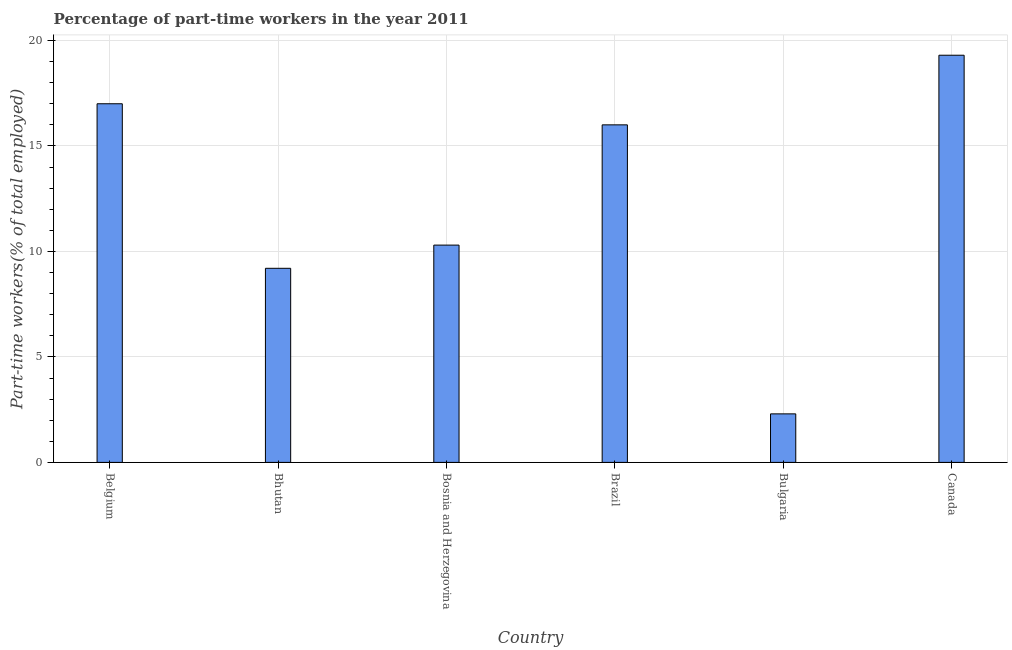Does the graph contain grids?
Your answer should be compact. Yes. What is the title of the graph?
Your answer should be compact. Percentage of part-time workers in the year 2011. What is the label or title of the X-axis?
Provide a short and direct response. Country. What is the label or title of the Y-axis?
Make the answer very short. Part-time workers(% of total employed). Across all countries, what is the maximum percentage of part-time workers?
Your answer should be compact. 19.3. Across all countries, what is the minimum percentage of part-time workers?
Keep it short and to the point. 2.3. In which country was the percentage of part-time workers maximum?
Provide a succinct answer. Canada. What is the sum of the percentage of part-time workers?
Provide a succinct answer. 74.1. What is the average percentage of part-time workers per country?
Give a very brief answer. 12.35. What is the median percentage of part-time workers?
Make the answer very short. 13.15. In how many countries, is the percentage of part-time workers greater than 13 %?
Provide a short and direct response. 3. What is the ratio of the percentage of part-time workers in Bosnia and Herzegovina to that in Bulgaria?
Give a very brief answer. 4.48. Is the difference between the percentage of part-time workers in Bosnia and Herzegovina and Bulgaria greater than the difference between any two countries?
Your response must be concise. No. What is the difference between the highest and the second highest percentage of part-time workers?
Offer a very short reply. 2.3. In how many countries, is the percentage of part-time workers greater than the average percentage of part-time workers taken over all countries?
Keep it short and to the point. 3. How many bars are there?
Your answer should be compact. 6. Are all the bars in the graph horizontal?
Provide a short and direct response. No. What is the Part-time workers(% of total employed) in Bhutan?
Ensure brevity in your answer.  9.2. What is the Part-time workers(% of total employed) in Bosnia and Herzegovina?
Provide a succinct answer. 10.3. What is the Part-time workers(% of total employed) of Bulgaria?
Keep it short and to the point. 2.3. What is the Part-time workers(% of total employed) in Canada?
Offer a terse response. 19.3. What is the difference between the Part-time workers(% of total employed) in Belgium and Bosnia and Herzegovina?
Your answer should be compact. 6.7. What is the difference between the Part-time workers(% of total employed) in Belgium and Brazil?
Make the answer very short. 1. What is the difference between the Part-time workers(% of total employed) in Belgium and Bulgaria?
Keep it short and to the point. 14.7. What is the difference between the Part-time workers(% of total employed) in Belgium and Canada?
Offer a very short reply. -2.3. What is the difference between the Part-time workers(% of total employed) in Bhutan and Brazil?
Offer a terse response. -6.8. What is the difference between the Part-time workers(% of total employed) in Bhutan and Canada?
Your response must be concise. -10.1. What is the difference between the Part-time workers(% of total employed) in Bosnia and Herzegovina and Bulgaria?
Your answer should be very brief. 8. What is the difference between the Part-time workers(% of total employed) in Bosnia and Herzegovina and Canada?
Your answer should be compact. -9. What is the difference between the Part-time workers(% of total employed) in Brazil and Canada?
Ensure brevity in your answer.  -3.3. What is the ratio of the Part-time workers(% of total employed) in Belgium to that in Bhutan?
Give a very brief answer. 1.85. What is the ratio of the Part-time workers(% of total employed) in Belgium to that in Bosnia and Herzegovina?
Provide a succinct answer. 1.65. What is the ratio of the Part-time workers(% of total employed) in Belgium to that in Brazil?
Your answer should be compact. 1.06. What is the ratio of the Part-time workers(% of total employed) in Belgium to that in Bulgaria?
Keep it short and to the point. 7.39. What is the ratio of the Part-time workers(% of total employed) in Belgium to that in Canada?
Offer a terse response. 0.88. What is the ratio of the Part-time workers(% of total employed) in Bhutan to that in Bosnia and Herzegovina?
Make the answer very short. 0.89. What is the ratio of the Part-time workers(% of total employed) in Bhutan to that in Brazil?
Your answer should be very brief. 0.57. What is the ratio of the Part-time workers(% of total employed) in Bhutan to that in Canada?
Your answer should be very brief. 0.48. What is the ratio of the Part-time workers(% of total employed) in Bosnia and Herzegovina to that in Brazil?
Offer a very short reply. 0.64. What is the ratio of the Part-time workers(% of total employed) in Bosnia and Herzegovina to that in Bulgaria?
Ensure brevity in your answer.  4.48. What is the ratio of the Part-time workers(% of total employed) in Bosnia and Herzegovina to that in Canada?
Your answer should be very brief. 0.53. What is the ratio of the Part-time workers(% of total employed) in Brazil to that in Bulgaria?
Provide a succinct answer. 6.96. What is the ratio of the Part-time workers(% of total employed) in Brazil to that in Canada?
Provide a succinct answer. 0.83. What is the ratio of the Part-time workers(% of total employed) in Bulgaria to that in Canada?
Provide a succinct answer. 0.12. 